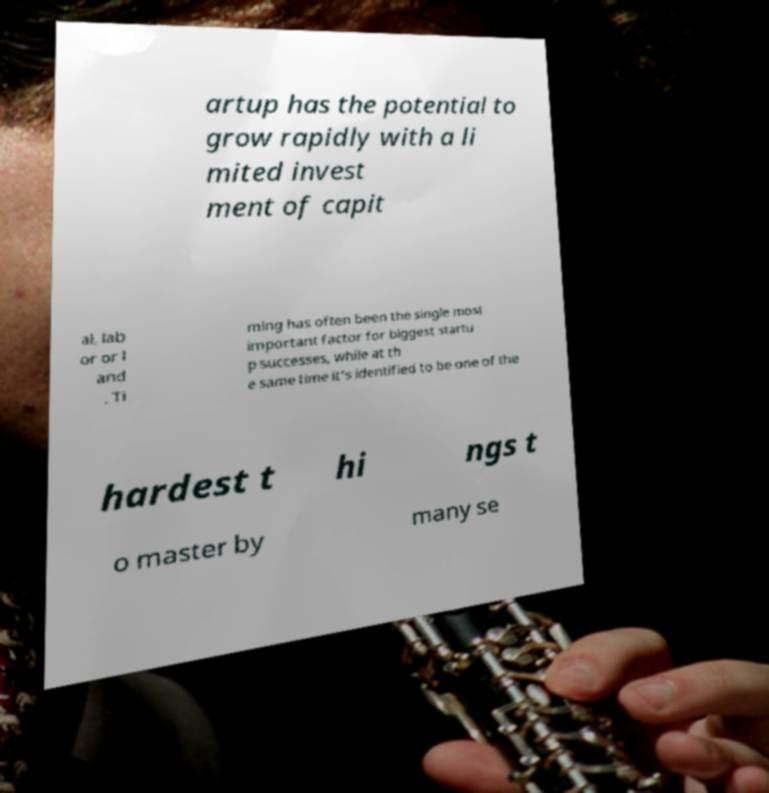Please identify and transcribe the text found in this image. artup has the potential to grow rapidly with a li mited invest ment of capit al, lab or or l and . Ti ming has often been the single most important factor for biggest startu p successes, while at th e same time it's identified to be one of the hardest t hi ngs t o master by many se 